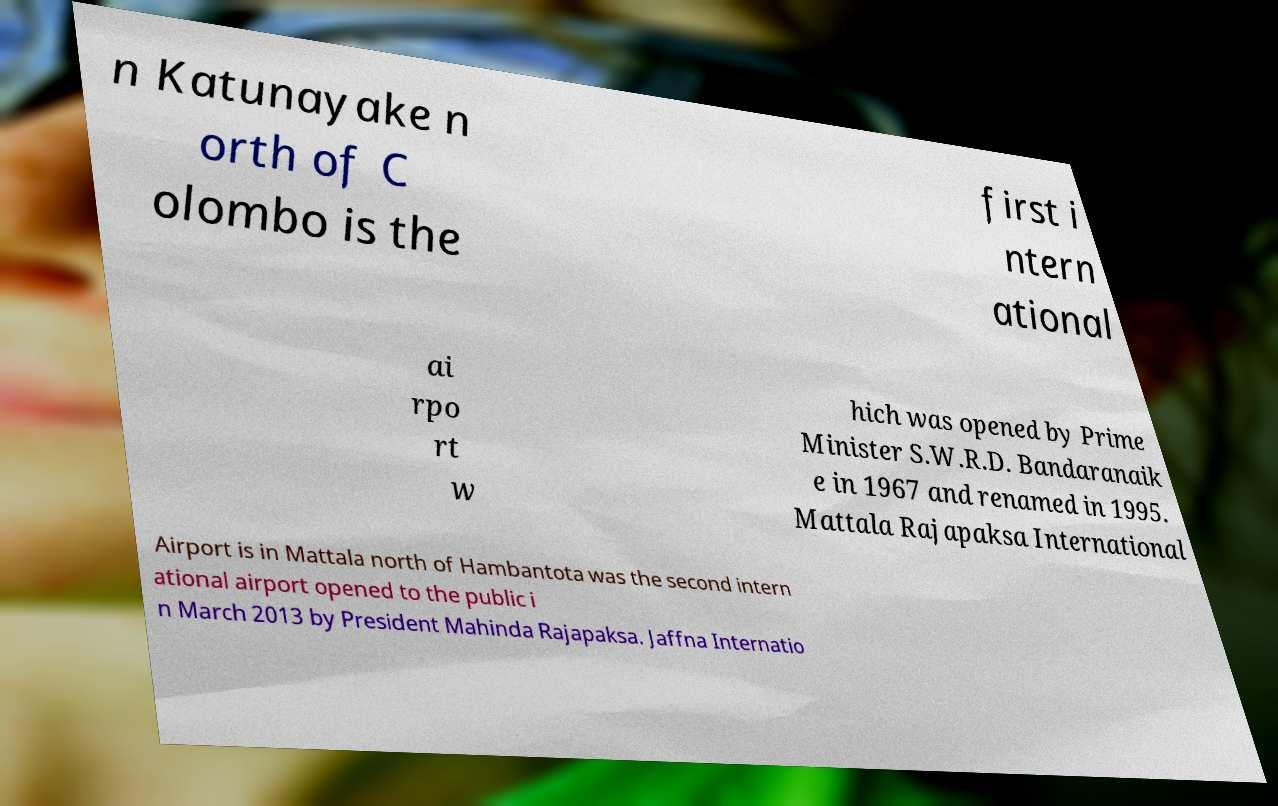Please read and relay the text visible in this image. What does it say? n Katunayake n orth of C olombo is the first i ntern ational ai rpo rt w hich was opened by Prime Minister S.W.R.D. Bandaranaik e in 1967 and renamed in 1995. Mattala Rajapaksa International Airport is in Mattala north of Hambantota was the second intern ational airport opened to the public i n March 2013 by President Mahinda Rajapaksa. Jaffna Internatio 